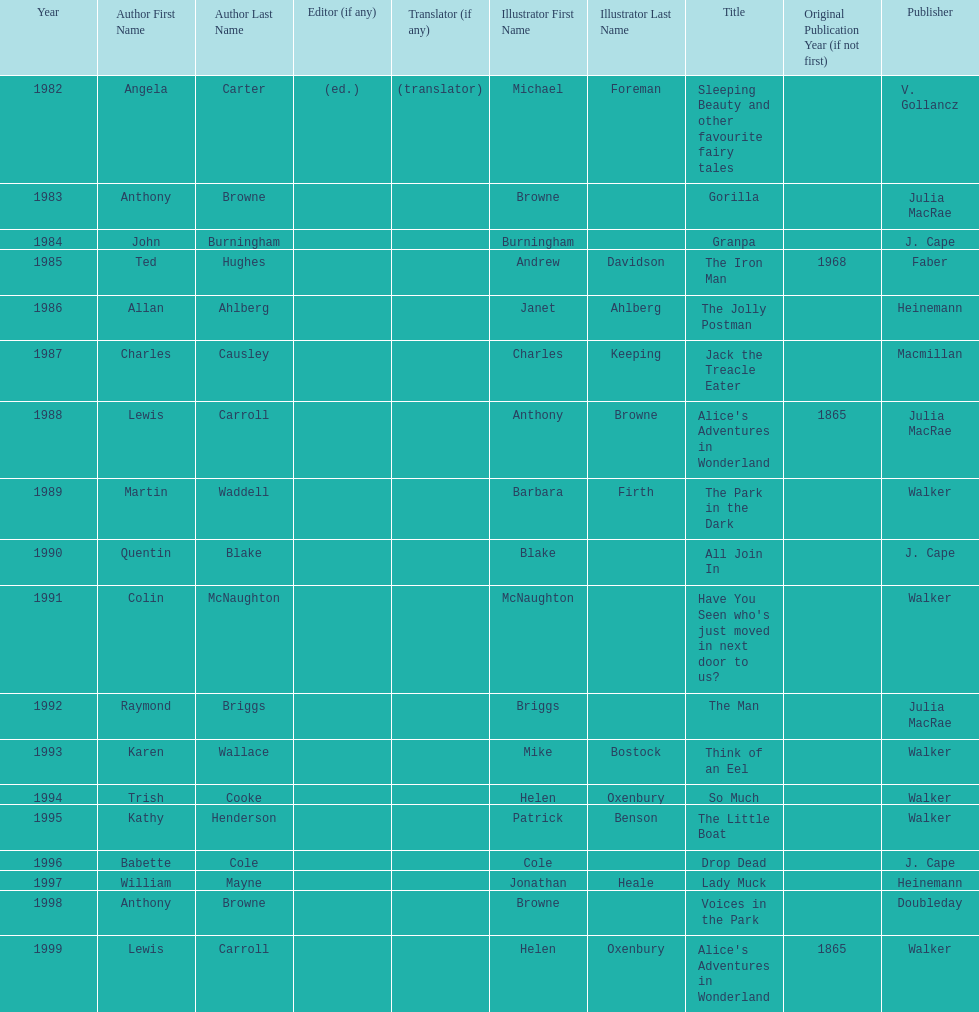Would you mind parsing the complete table? {'header': ['Year', 'Author First Name', 'Author Last Name', 'Editor (if any)', 'Translator (if any)', 'Illustrator First Name', 'Illustrator Last Name', 'Title', 'Original Publication Year (if not first)', 'Publisher'], 'rows': [['1982', 'Angela', 'Carter', '(ed.)', '(translator)', 'Michael', 'Foreman', 'Sleeping Beauty and other favourite fairy tales', '', 'V. Gollancz'], ['1983', 'Anthony', 'Browne', '', '', 'Browne', '', 'Gorilla', '', 'Julia MacRae'], ['1984', 'John', 'Burningham', '', '', 'Burningham', '', 'Granpa', '', 'J. Cape'], ['1985', 'Ted', 'Hughes', '', '', 'Andrew', 'Davidson', 'The Iron Man', '1968', 'Faber'], ['1986', 'Allan', 'Ahlberg', '', '', 'Janet', 'Ahlberg', 'The Jolly Postman', '', 'Heinemann'], ['1987', 'Charles', 'Causley', '', '', 'Charles', 'Keeping', 'Jack the Treacle Eater', '', 'Macmillan'], ['1988', 'Lewis', 'Carroll', '', '', 'Anthony', 'Browne', "Alice's Adventures in Wonderland", '1865', 'Julia MacRae'], ['1989', 'Martin', 'Waddell', '', '', 'Barbara', 'Firth', 'The Park in the Dark', '', 'Walker'], ['1990', 'Quentin', 'Blake', '', '', 'Blake', '', 'All Join In', '', 'J. Cape'], ['1991', 'Colin', 'McNaughton', '', '', 'McNaughton', '', "Have You Seen who's just moved in next door to us?", '', 'Walker'], ['1992', 'Raymond', 'Briggs', '', '', 'Briggs', '', 'The Man', '', 'Julia MacRae'], ['1993', 'Karen', 'Wallace', '', '', 'Mike', 'Bostock', 'Think of an Eel', '', 'Walker'], ['1994', 'Trish', 'Cooke', '', '', 'Helen', 'Oxenbury', 'So Much', '', 'Walker'], ['1995', 'Kathy', 'Henderson', '', '', 'Patrick', 'Benson', 'The Little Boat', '', 'Walker'], ['1996', 'Babette', 'Cole', '', '', 'Cole', '', 'Drop Dead', '', 'J. Cape'], ['1997', 'William', 'Mayne', '', '', 'Jonathan', 'Heale', 'Lady Muck', '', 'Heinemann'], ['1998', 'Anthony', 'Browne', '', '', 'Browne', '', 'Voices in the Park', '', 'Doubleday'], ['1999', 'Lewis', 'Carroll', '', '', 'Helen', 'Oxenbury', "Alice's Adventures in Wonderland", '1865', 'Walker']]} How many times has anthony browne won an kurt maschler award for illustration? 3. 